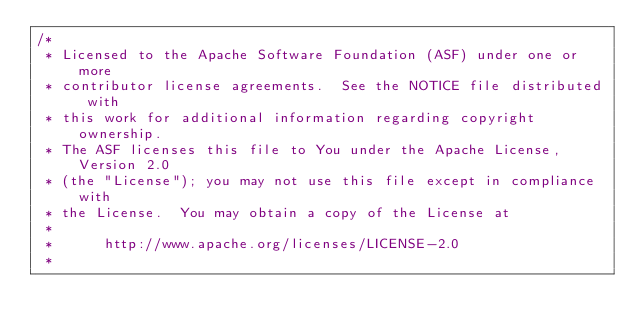Convert code to text. <code><loc_0><loc_0><loc_500><loc_500><_Java_>/*
 * Licensed to the Apache Software Foundation (ASF) under one or more
 * contributor license agreements.  See the NOTICE file distributed with
 * this work for additional information regarding copyright ownership.
 * The ASF licenses this file to You under the Apache License, Version 2.0
 * (the "License"); you may not use this file except in compliance with
 * the License.  You may obtain a copy of the License at
 *
 *      http://www.apache.org/licenses/LICENSE-2.0
 *</code> 